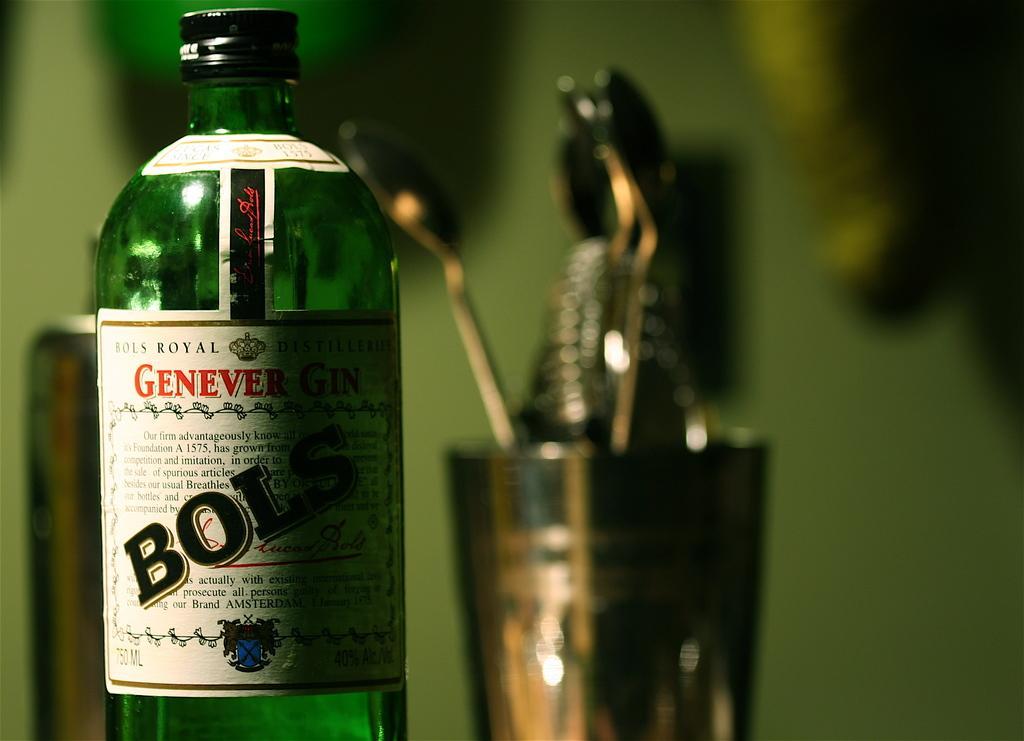In one or two sentences, can you explain what this image depicts? In this image I can see a bottle where BOLS is written on it. In the background I can see a glass and few spoons. 